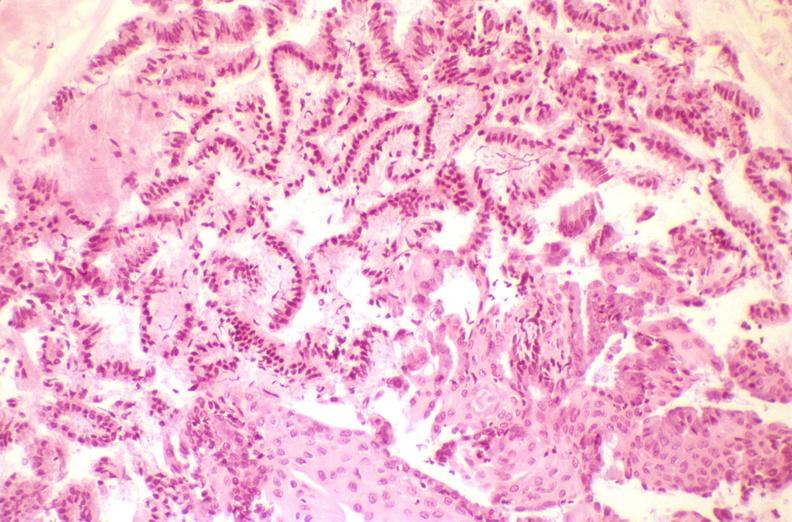does this image show cervix, squamous metaplasia?
Answer the question using a single word or phrase. Yes 